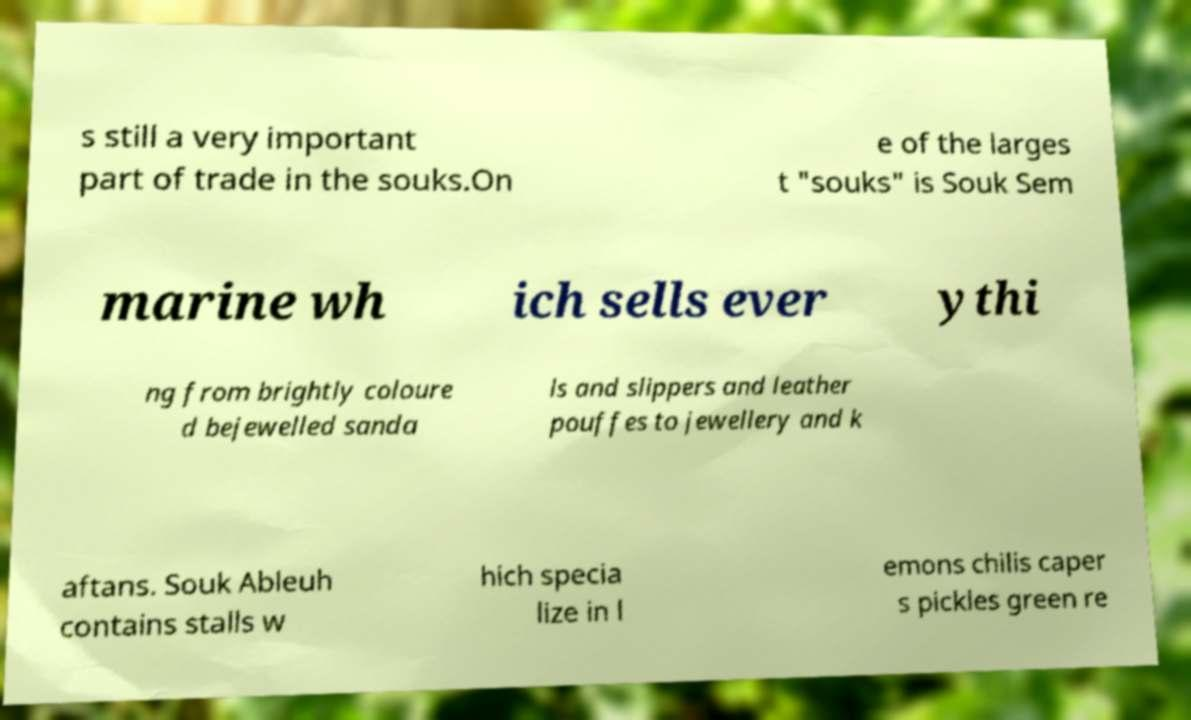Please identify and transcribe the text found in this image. s still a very important part of trade in the souks.On e of the larges t "souks" is Souk Sem marine wh ich sells ever ythi ng from brightly coloure d bejewelled sanda ls and slippers and leather pouffes to jewellery and k aftans. Souk Ableuh contains stalls w hich specia lize in l emons chilis caper s pickles green re 